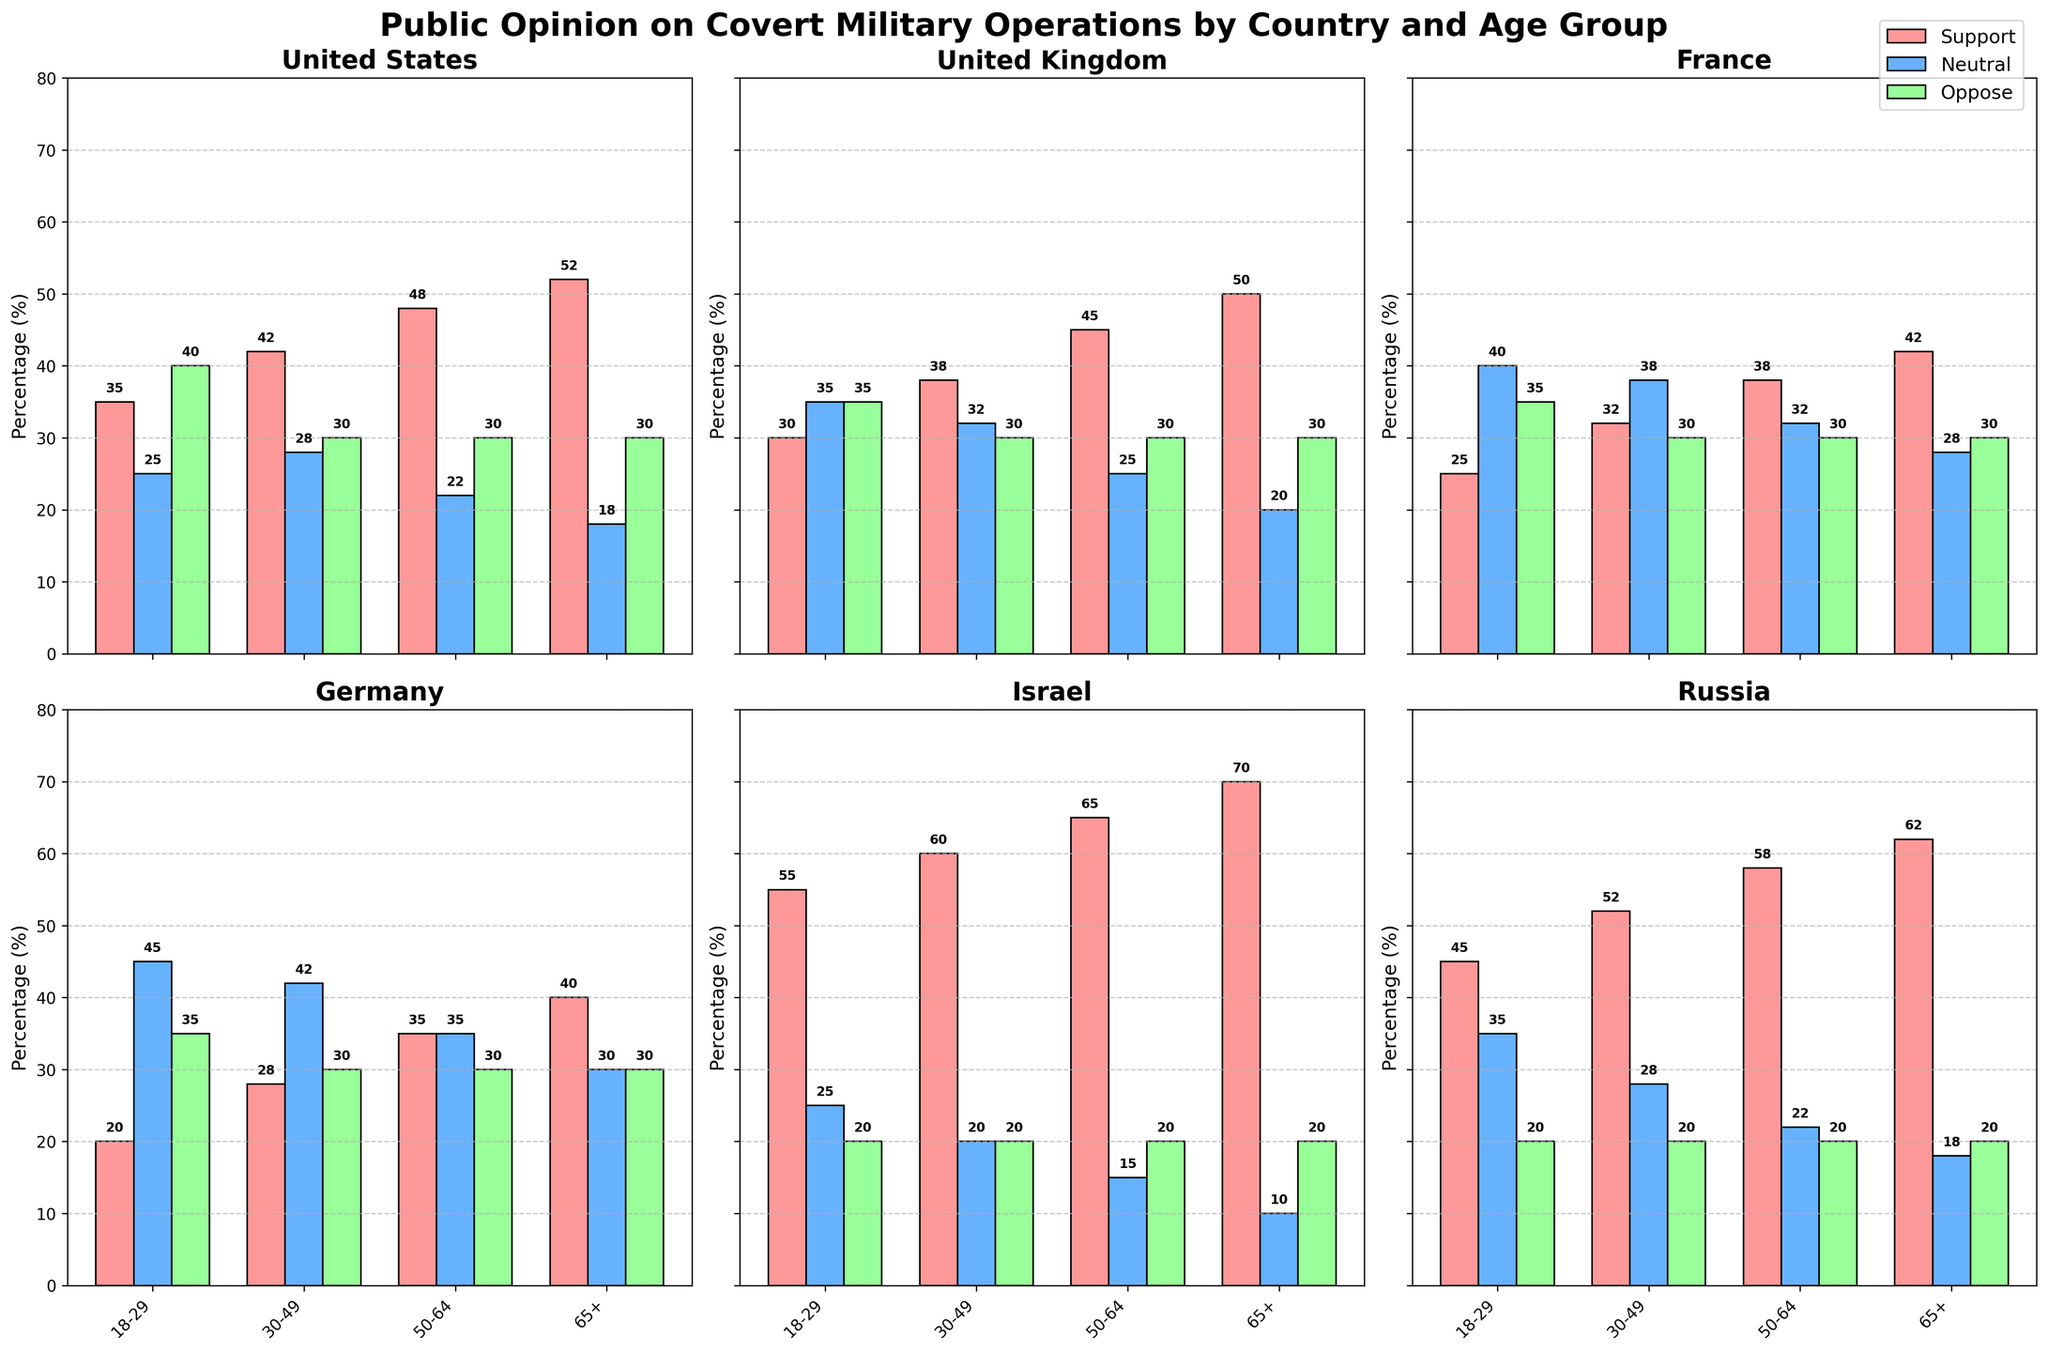Which country has the highest support percentage among the 65+ age group? To find the highest support percentage among the 65+ age group, we need to compare the support percentages for each country in the 65+ category. The values are: United States (52%), United Kingdom (50%), France (42%), Germany (40%), Israel (70%), and Russia (62%). Israel has the highest support percentage of 70%.
Answer: Israel In the United States, what is the difference in the support percentage between the 18-29 and 65+ age groups? The support percentage for the 18-29 age group in the United States is 35%, and for the 65+ age group, it is 52%. The difference is 52% - 35% = 17%.
Answer: 17% Which country has the lowest neutral opinion in the 50-64 age group? To find the lowest neutral opinion in the 50-64 age group, we compare the neutral percentages: United States (22%), United Kingdom (25%), France (32%), Germany (35%), Israel (15%), and Russia (22%). Israel has the lowest neutral opinion at 15%.
Answer: Israel Are there any age groups where the opposition percentage is the same across all countries? By examining each age group, we see if any opposition percentages match across all countries. In the 50-64 and 65+ age groups, the opposition percentage is consistently 30% across all countries.
Answer: Yes Which country shows the most significant increase in support from the 18-29 to the 65+ age groups? To determine the most significant increase, we calculate the difference in support percentages between the 18-29 and 65+ age groups for each country: United States (52% - 35% = 17%), United Kingdom (50% - 30% = 20%), France (42% - 25% = 17%), Germany (40% - 20% = 20%), Israel (70% - 55% = 15%), and Russia (62% - 45% = 17%). Both the United Kingdom and Germany show the largest increase of 20%.
Answer: United Kingdom and Germany In which age group does Germany have the highest opposition percentage? By looking at the opposition percentages for Germany across all age groups, we find: 18-29 (35%), 30-49 (30%), 50-64 (30%), and 65+ (30%). The highest opposition percentage is for the 18-29 age group at 35%.
Answer: 18-29 What is the average support percentage for the 30-49 age group across all countries? To calculate the average support percentage for the 30-49 age group, we sum the support percentages for each country and then divide by the number of countries: (42% + 38% + 32% + 28% + 60% + 52%) / 6 = 42%.
Answer: 42% Which age group in France has the closest balance between support, neutral, and oppose percentages? We need to compare the support, neutral, and oppose percentages for France in each age group and see which one has the closest values: 18-29 (25%, 40%, 35%), 30-49 (32%, 38%, 30%), 50-64 (38%, 32%, 30%), and 65+ (42%, 28%, 30%). The 30-49 age group has the most balanced values with the smallest range of differences.
Answer: 30-49 